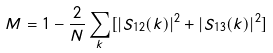Convert formula to latex. <formula><loc_0><loc_0><loc_500><loc_500>M = 1 - \frac { 2 } { N } \sum _ { k } [ | S _ { 1 2 } ( { k } ) | ^ { 2 } + | S _ { 1 3 } ( { k } ) | ^ { 2 } ]</formula> 